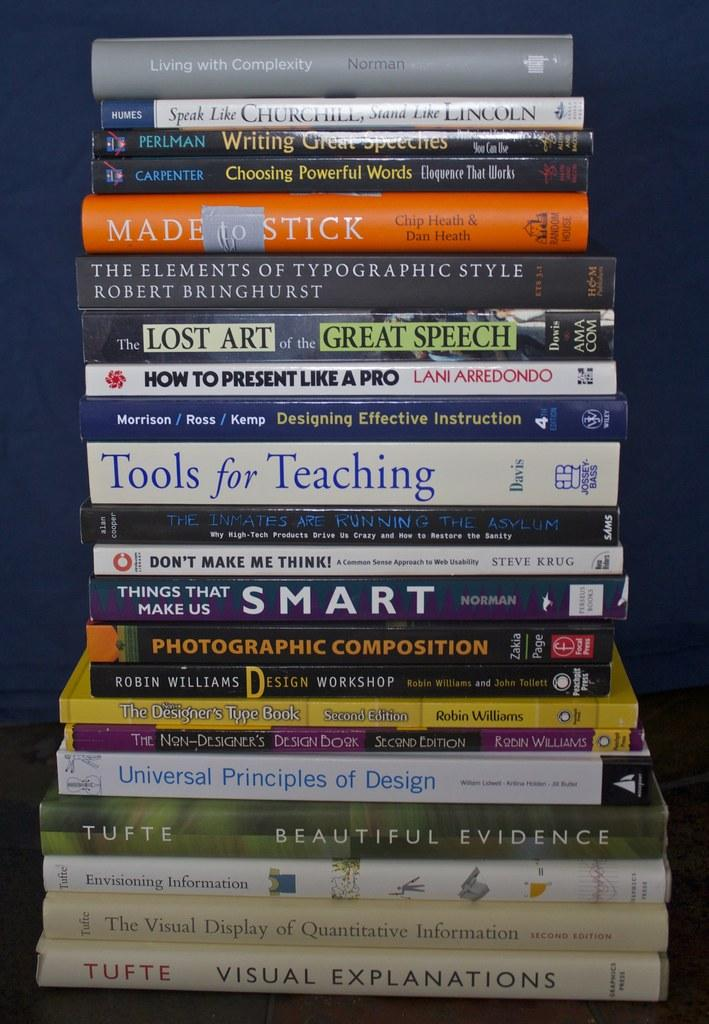<image>
Create a compact narrative representing the image presented. a stack of books with the book 'visual explanations' at the bottom of it 